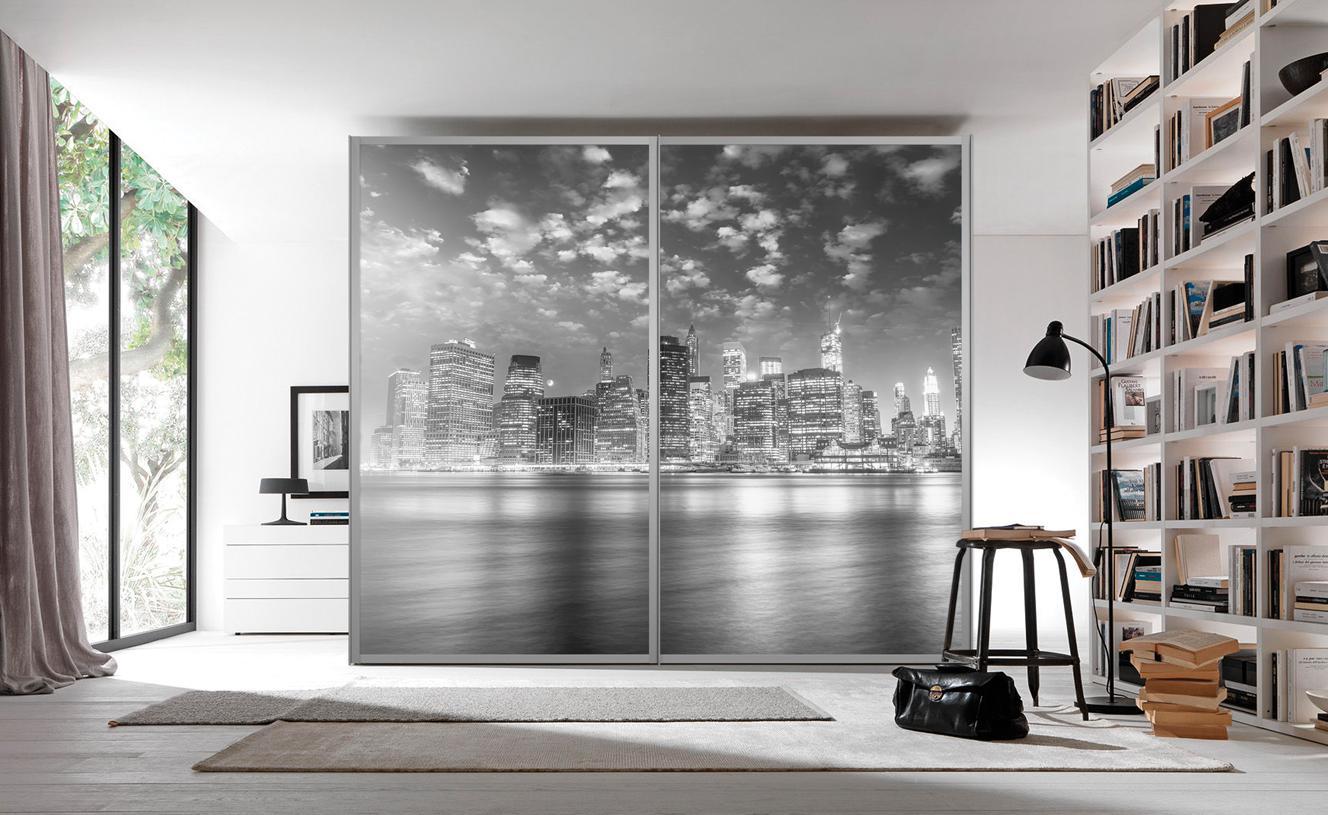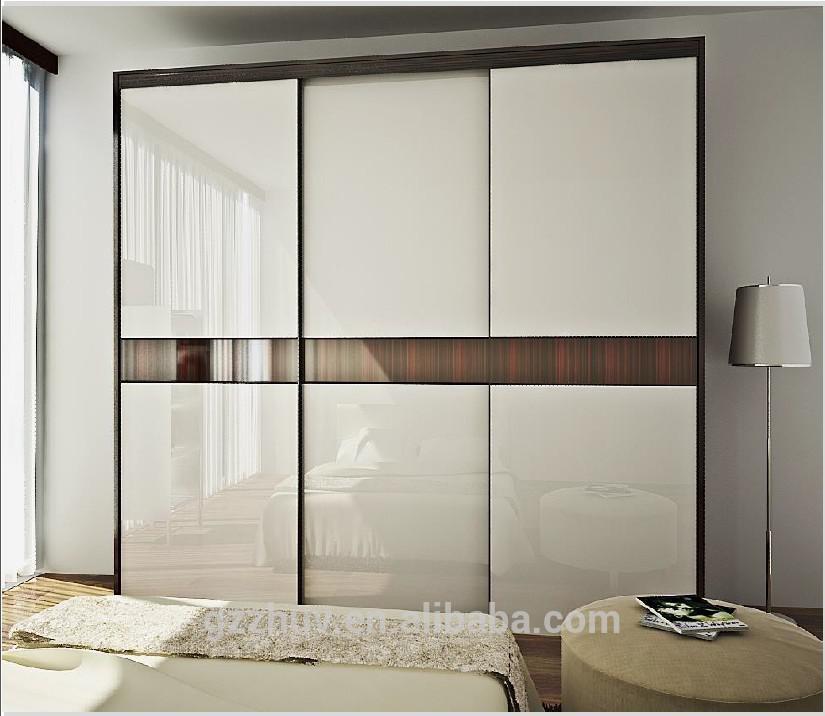The first image is the image on the left, the second image is the image on the right. For the images displayed, is the sentence "A cushioned chair sits outside a door in the image on the left." factually correct? Answer yes or no. No. The first image is the image on the left, the second image is the image on the right. Analyze the images presented: Is the assertion "One closet's doors has a photographic image design." valid? Answer yes or no. Yes. 